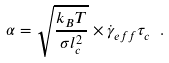<formula> <loc_0><loc_0><loc_500><loc_500>\alpha = \sqrt { \frac { k _ { B } T } { \sigma l _ { c } ^ { 2 } } } \times \dot { \gamma } _ { e f f } \tau _ { c } \ .</formula> 